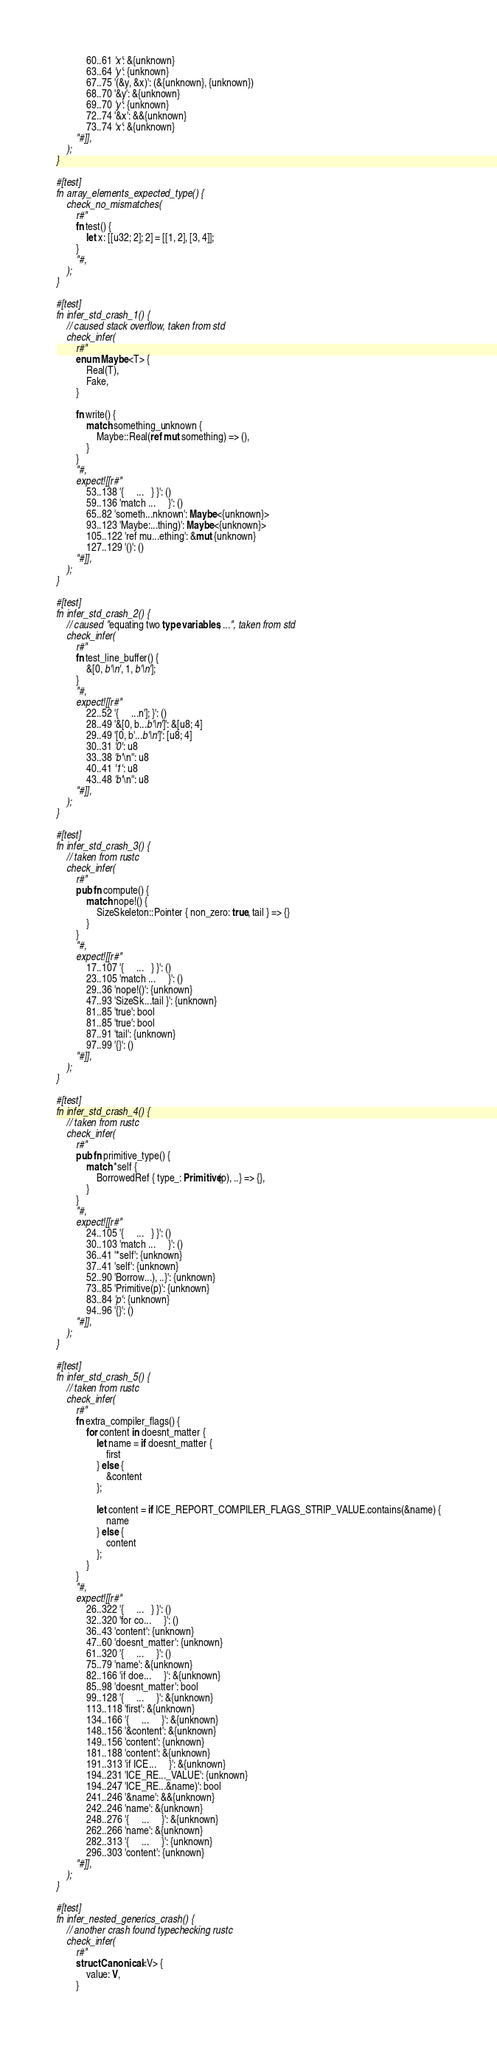<code> <loc_0><loc_0><loc_500><loc_500><_Rust_>            60..61 'x': &{unknown}
            63..64 'y': {unknown}
            67..75 '(&y, &x)': (&{unknown}, {unknown})
            68..70 '&y': &{unknown}
            69..70 'y': {unknown}
            72..74 '&x': &&{unknown}
            73..74 'x': &{unknown}
        "#]],
    );
}

#[test]
fn array_elements_expected_type() {
    check_no_mismatches(
        r#"
        fn test() {
            let x: [[u32; 2]; 2] = [[1, 2], [3, 4]];
        }
        "#,
    );
}

#[test]
fn infer_std_crash_1() {
    // caused stack overflow, taken from std
    check_infer(
        r#"
        enum Maybe<T> {
            Real(T),
            Fake,
        }

        fn write() {
            match something_unknown {
                Maybe::Real(ref mut something) => (),
            }
        }
        "#,
        expect![[r#"
            53..138 '{     ...   } }': ()
            59..136 'match ...     }': ()
            65..82 'someth...nknown': Maybe<{unknown}>
            93..123 'Maybe:...thing)': Maybe<{unknown}>
            105..122 'ref mu...ething': &mut {unknown}
            127..129 '()': ()
        "#]],
    );
}

#[test]
fn infer_std_crash_2() {
    // caused "equating two type variables, ...", taken from std
    check_infer(
        r#"
        fn test_line_buffer() {
            &[0, b'\n', 1, b'\n'];
        }
        "#,
        expect![[r#"
            22..52 '{     ...n']; }': ()
            28..49 '&[0, b...b'\n']': &[u8; 4]
            29..49 '[0, b'...b'\n']': [u8; 4]
            30..31 '0': u8
            33..38 'b'\n'': u8
            40..41 '1': u8
            43..48 'b'\n'': u8
        "#]],
    );
}

#[test]
fn infer_std_crash_3() {
    // taken from rustc
    check_infer(
        r#"
        pub fn compute() {
            match nope!() {
                SizeSkeleton::Pointer { non_zero: true, tail } => {}
            }
        }
        "#,
        expect![[r#"
            17..107 '{     ...   } }': ()
            23..105 'match ...     }': ()
            29..36 'nope!()': {unknown}
            47..93 'SizeSk...tail }': {unknown}
            81..85 'true': bool
            81..85 'true': bool
            87..91 'tail': {unknown}
            97..99 '{}': ()
        "#]],
    );
}

#[test]
fn infer_std_crash_4() {
    // taken from rustc
    check_infer(
        r#"
        pub fn primitive_type() {
            match *self {
                BorrowedRef { type_: Primitive(p), ..} => {},
            }
        }
        "#,
        expect![[r#"
            24..105 '{     ...   } }': ()
            30..103 'match ...     }': ()
            36..41 '*self': {unknown}
            37..41 'self': {unknown}
            52..90 'Borrow...), ..}': {unknown}
            73..85 'Primitive(p)': {unknown}
            83..84 'p': {unknown}
            94..96 '{}': ()
        "#]],
    );
}

#[test]
fn infer_std_crash_5() {
    // taken from rustc
    check_infer(
        r#"
        fn extra_compiler_flags() {
            for content in doesnt_matter {
                let name = if doesnt_matter {
                    first
                } else {
                    &content
                };

                let content = if ICE_REPORT_COMPILER_FLAGS_STRIP_VALUE.contains(&name) {
                    name
                } else {
                    content
                };
            }
        }
        "#,
        expect![[r#"
            26..322 '{     ...   } }': ()
            32..320 'for co...     }': ()
            36..43 'content': {unknown}
            47..60 'doesnt_matter': {unknown}
            61..320 '{     ...     }': ()
            75..79 'name': &{unknown}
            82..166 'if doe...     }': &{unknown}
            85..98 'doesnt_matter': bool
            99..128 '{     ...     }': &{unknown}
            113..118 'first': &{unknown}
            134..166 '{     ...     }': &{unknown}
            148..156 '&content': &{unknown}
            149..156 'content': {unknown}
            181..188 'content': &{unknown}
            191..313 'if ICE...     }': &{unknown}
            194..231 'ICE_RE..._VALUE': {unknown}
            194..247 'ICE_RE...&name)': bool
            241..246 '&name': &&{unknown}
            242..246 'name': &{unknown}
            248..276 '{     ...     }': &{unknown}
            262..266 'name': &{unknown}
            282..313 '{     ...     }': {unknown}
            296..303 'content': {unknown}
        "#]],
    );
}

#[test]
fn infer_nested_generics_crash() {
    // another crash found typechecking rustc
    check_infer(
        r#"
        struct Canonical<V> {
            value: V,
        }</code> 